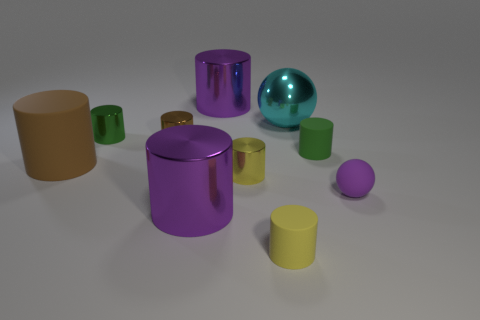There is a tiny rubber sphere right of the big ball; what color is it?
Provide a succinct answer. Purple. How many metallic things are small green things or big cyan objects?
Keep it short and to the point. 2. There is a tiny green cylinder on the right side of the purple cylinder that is behind the tiny brown cylinder; what is it made of?
Make the answer very short. Rubber. What is the color of the tiny rubber ball?
Keep it short and to the point. Purple. There is a tiny rubber object in front of the small purple matte thing; is there a green cylinder on the right side of it?
Offer a very short reply. Yes. What is the cyan object made of?
Offer a terse response. Metal. Do the purple cylinder that is behind the cyan shiny object and the purple cylinder in front of the large brown thing have the same material?
Your answer should be compact. Yes. Is there any other thing of the same color as the large rubber cylinder?
Make the answer very short. Yes. There is a large matte object that is the same shape as the yellow shiny object; what is its color?
Keep it short and to the point. Brown. There is a purple object that is both left of the large cyan thing and in front of the small green rubber object; how big is it?
Make the answer very short. Large. 